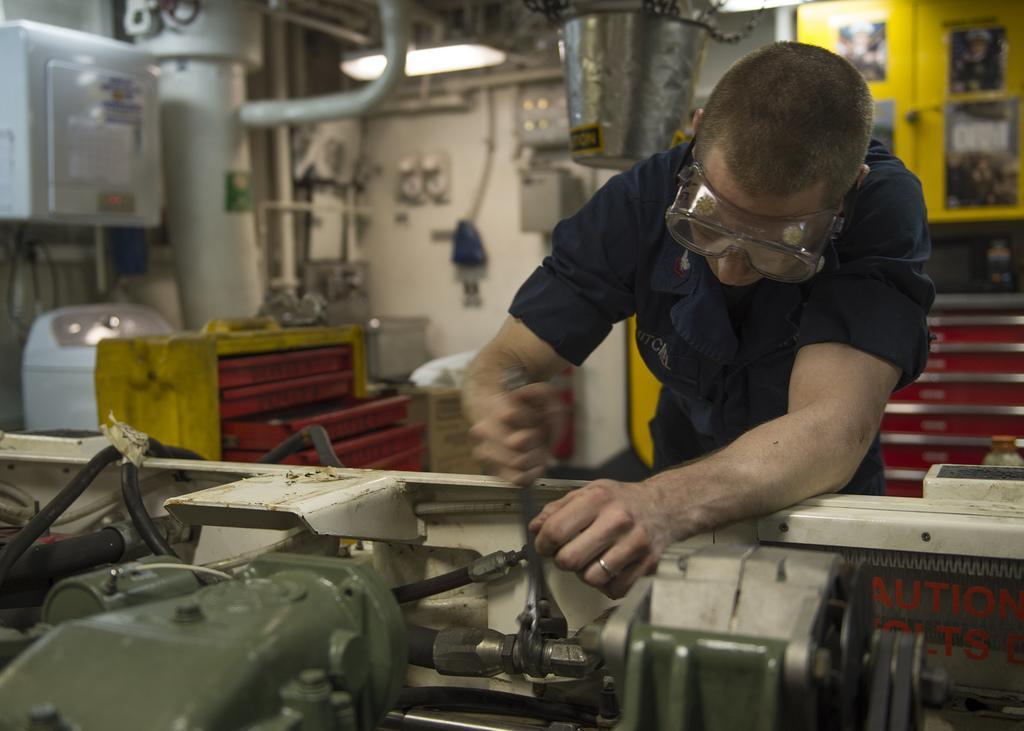How would you summarize this image in a sentence or two? In this image there is a person standing and repairing a machine, and at the background there is light, cupboard, and some machines. 